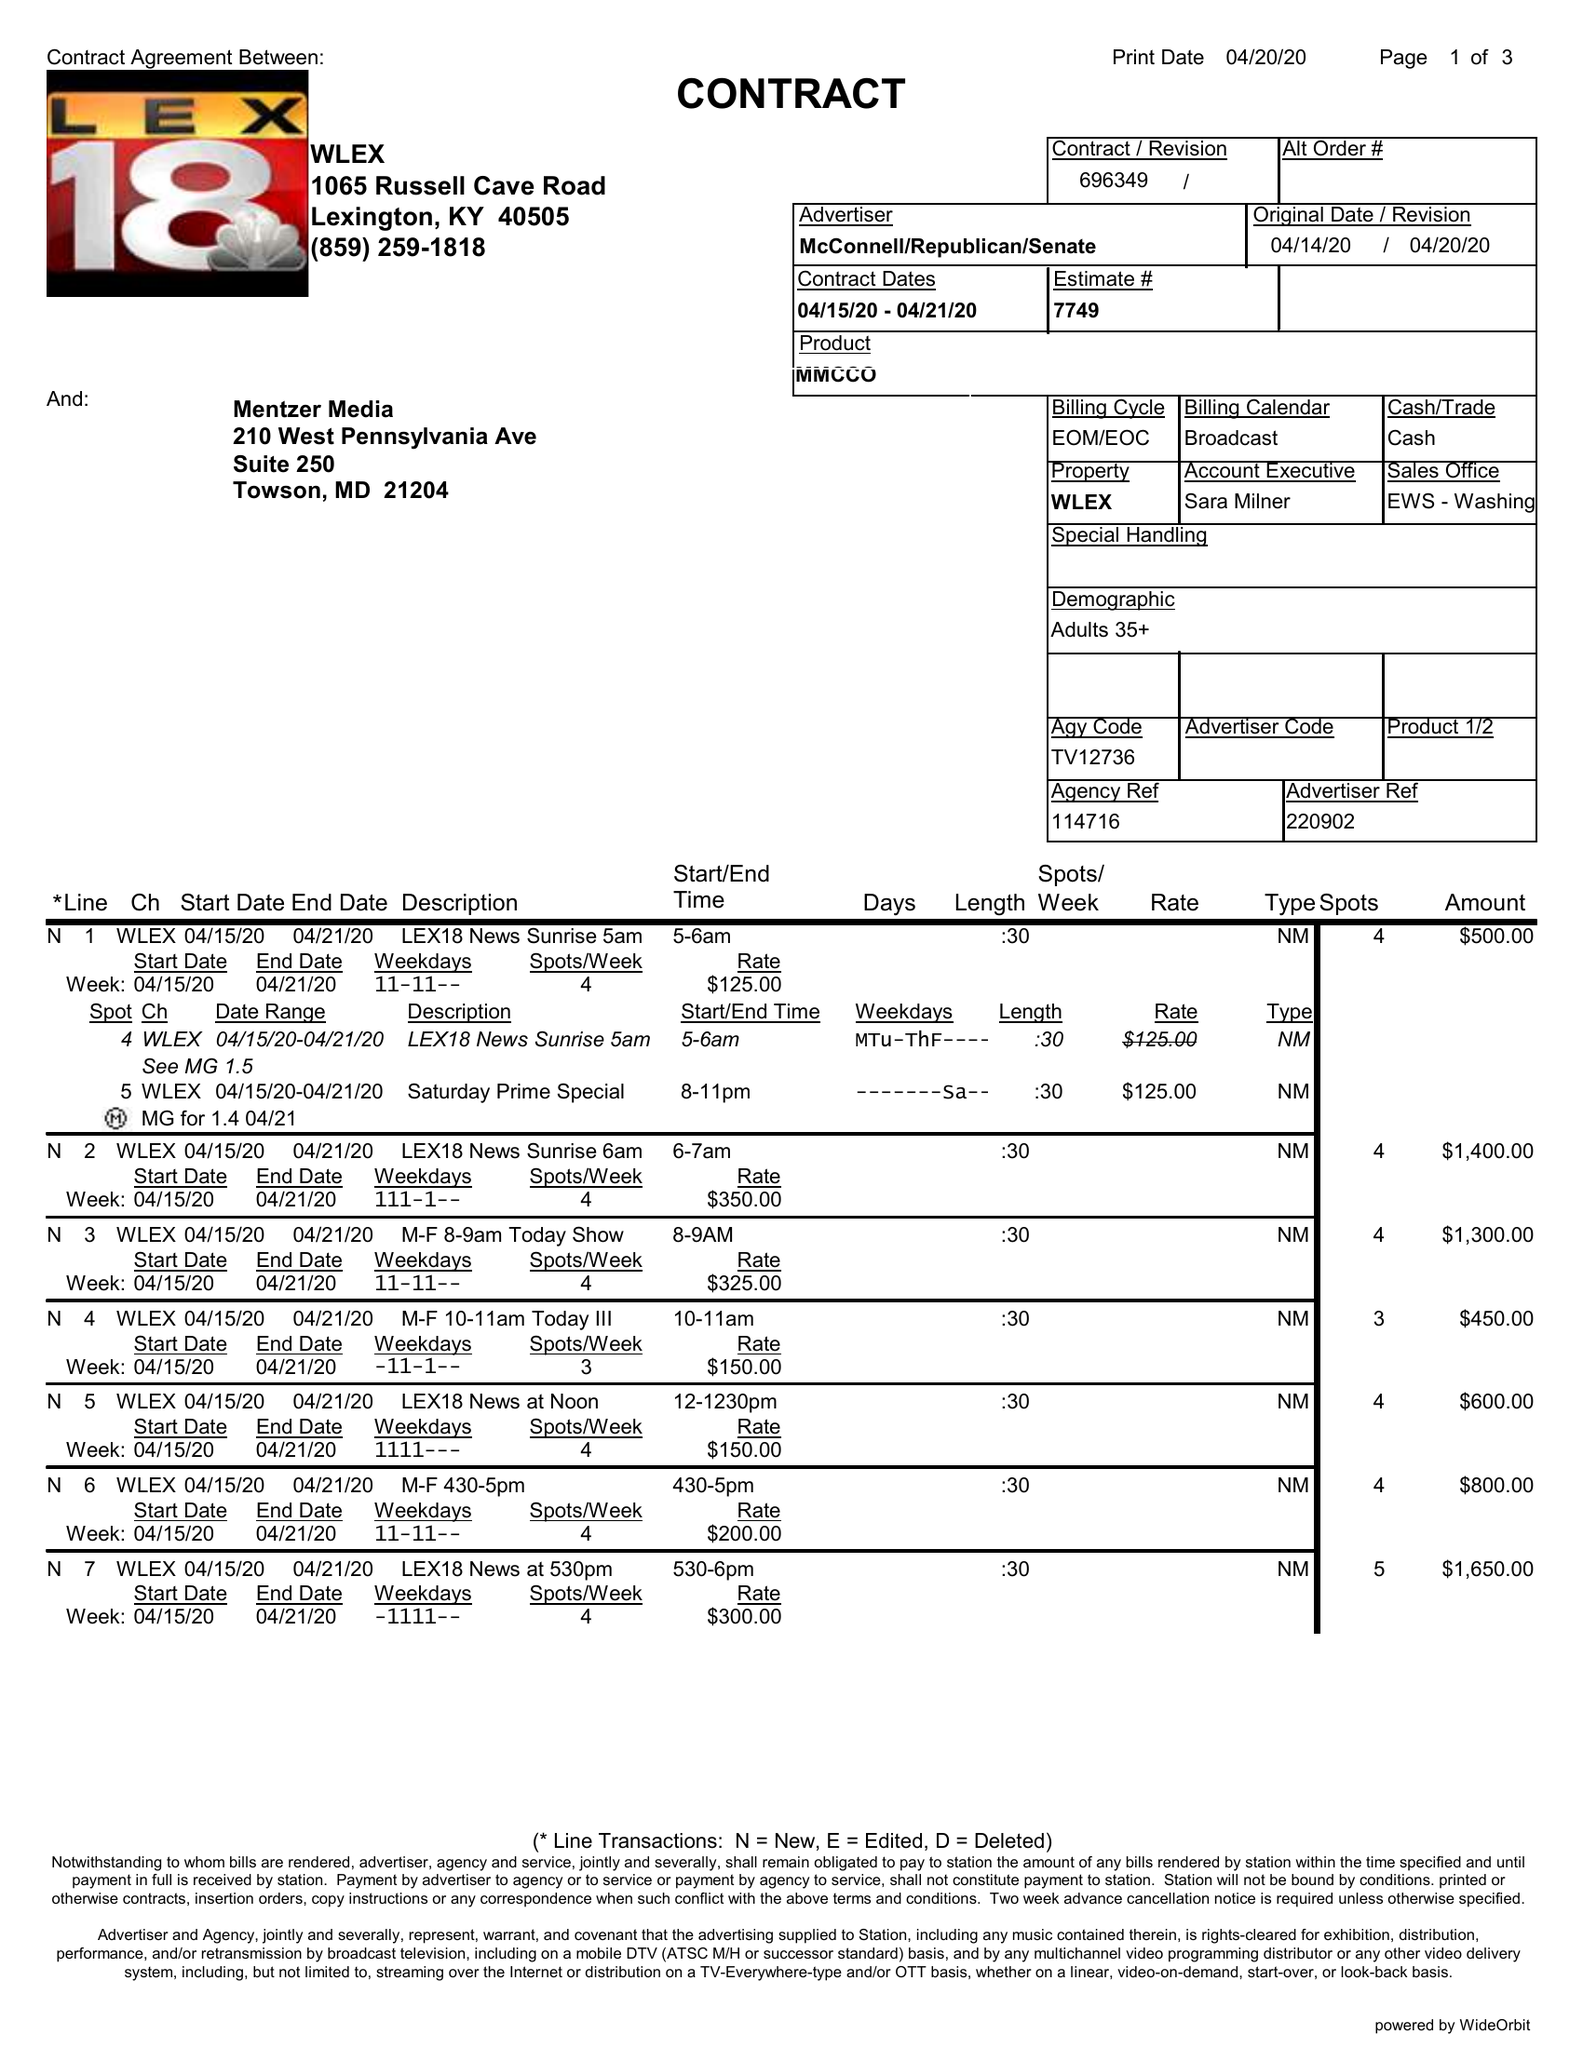What is the value for the flight_from?
Answer the question using a single word or phrase. 04/15/20 